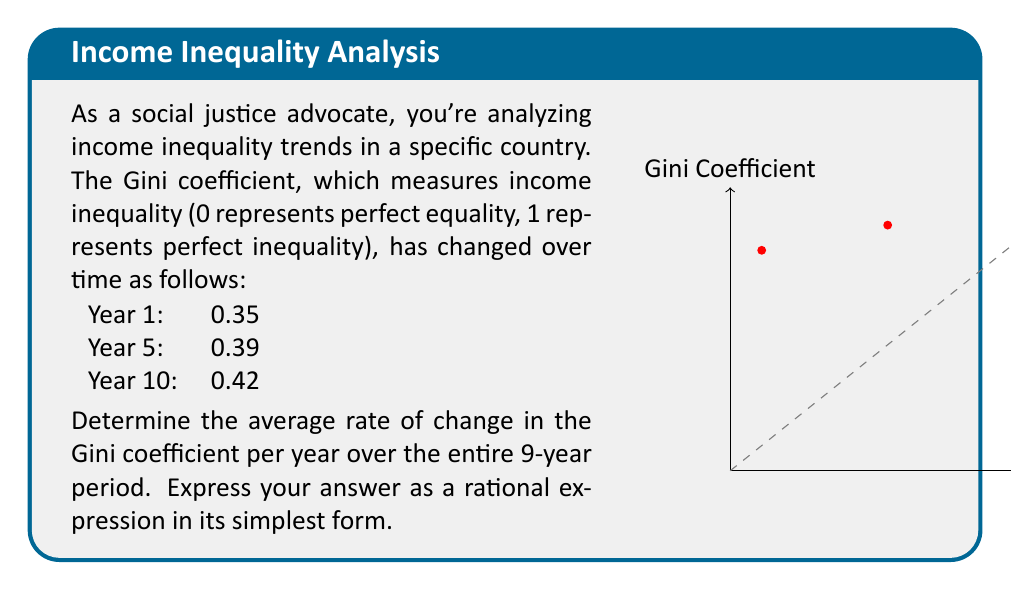Show me your answer to this math problem. To solve this problem, we'll follow these steps:

1) The rate of change is given by the formula:
   $$\text{Rate of change} = \frac{\text{Change in y}}{\text{Change in x}}$$

2) In this case:
   - Change in y = Change in Gini coefficient = Final value - Initial value
   - Change in x = Change in time (years)

3) Calculate the change in Gini coefficient:
   $$0.42 - 0.35 = 0.07$$

4) Calculate the change in time:
   $$10 - 1 = 9 \text{ years}$$

5) Apply the rate of change formula:
   $$\text{Rate of change} = \frac{0.07}{9} \text{ per year}$$

6) Simplify the fraction:
   $$\frac{0.07}{9} = \frac{7}{900} = \frac{7}{900} \cdot \frac{1}{1} = \frac{7}{900}$$

This fraction is already in its simplest form as 7 and 900 have no common factors other than 1.
Answer: $\frac{7}{900}$ per year 